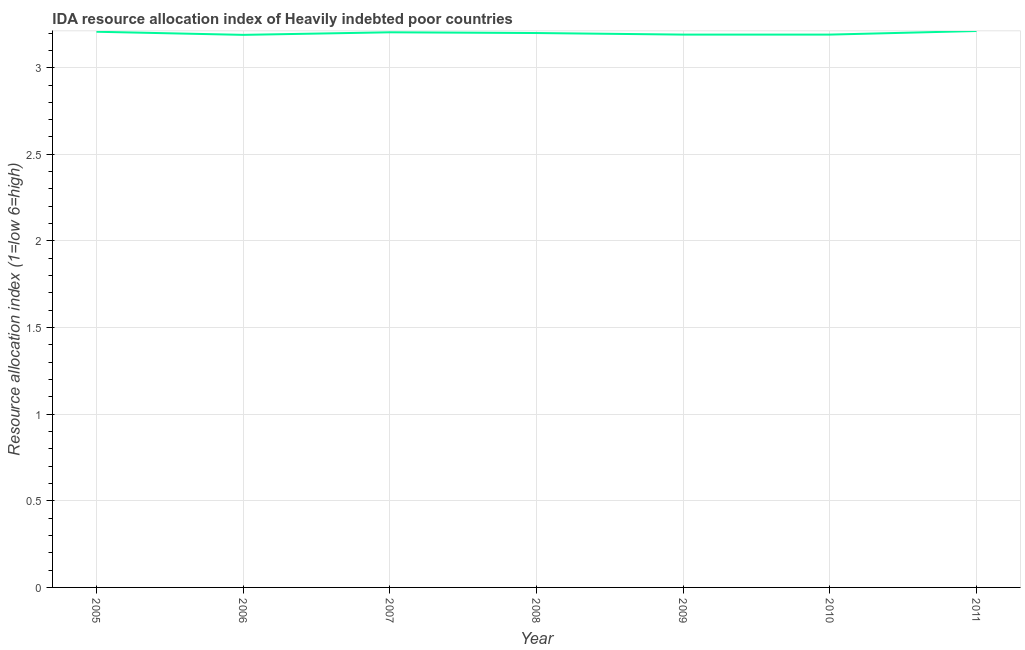What is the ida resource allocation index in 2011?
Offer a terse response. 3.21. Across all years, what is the maximum ida resource allocation index?
Offer a terse response. 3.21. Across all years, what is the minimum ida resource allocation index?
Provide a succinct answer. 3.19. In which year was the ida resource allocation index maximum?
Your answer should be very brief. 2011. What is the sum of the ida resource allocation index?
Provide a short and direct response. 22.39. What is the difference between the ida resource allocation index in 2006 and 2007?
Your response must be concise. -0.01. What is the average ida resource allocation index per year?
Make the answer very short. 3.2. Do a majority of the years between 2009 and 2011 (inclusive) have ida resource allocation index greater than 1.5 ?
Your answer should be very brief. Yes. Is the ida resource allocation index in 2009 less than that in 2010?
Offer a terse response. No. Is the difference between the ida resource allocation index in 2010 and 2011 greater than the difference between any two years?
Keep it short and to the point. No. What is the difference between the highest and the second highest ida resource allocation index?
Your answer should be very brief. 0. What is the difference between the highest and the lowest ida resource allocation index?
Provide a short and direct response. 0.02. What is the difference between two consecutive major ticks on the Y-axis?
Provide a succinct answer. 0.5. Are the values on the major ticks of Y-axis written in scientific E-notation?
Give a very brief answer. No. Does the graph contain any zero values?
Offer a very short reply. No. Does the graph contain grids?
Offer a terse response. Yes. What is the title of the graph?
Give a very brief answer. IDA resource allocation index of Heavily indebted poor countries. What is the label or title of the Y-axis?
Provide a succinct answer. Resource allocation index (1=low 6=high). What is the Resource allocation index (1=low 6=high) of 2005?
Your response must be concise. 3.21. What is the Resource allocation index (1=low 6=high) in 2006?
Your answer should be compact. 3.19. What is the Resource allocation index (1=low 6=high) of 2007?
Make the answer very short. 3.2. What is the Resource allocation index (1=low 6=high) in 2008?
Make the answer very short. 3.2. What is the Resource allocation index (1=low 6=high) of 2009?
Offer a very short reply. 3.19. What is the Resource allocation index (1=low 6=high) in 2010?
Your response must be concise. 3.19. What is the Resource allocation index (1=low 6=high) in 2011?
Ensure brevity in your answer.  3.21. What is the difference between the Resource allocation index (1=low 6=high) in 2005 and 2006?
Offer a terse response. 0.02. What is the difference between the Resource allocation index (1=low 6=high) in 2005 and 2007?
Ensure brevity in your answer.  0. What is the difference between the Resource allocation index (1=low 6=high) in 2005 and 2008?
Give a very brief answer. 0.01. What is the difference between the Resource allocation index (1=low 6=high) in 2005 and 2009?
Keep it short and to the point. 0.02. What is the difference between the Resource allocation index (1=low 6=high) in 2005 and 2010?
Your answer should be very brief. 0.02. What is the difference between the Resource allocation index (1=low 6=high) in 2005 and 2011?
Provide a short and direct response. -0. What is the difference between the Resource allocation index (1=low 6=high) in 2006 and 2007?
Provide a succinct answer. -0.01. What is the difference between the Resource allocation index (1=low 6=high) in 2006 and 2008?
Provide a succinct answer. -0.01. What is the difference between the Resource allocation index (1=low 6=high) in 2006 and 2009?
Your response must be concise. -0. What is the difference between the Resource allocation index (1=low 6=high) in 2006 and 2010?
Your response must be concise. -0. What is the difference between the Resource allocation index (1=low 6=high) in 2006 and 2011?
Give a very brief answer. -0.02. What is the difference between the Resource allocation index (1=low 6=high) in 2007 and 2008?
Provide a succinct answer. 0. What is the difference between the Resource allocation index (1=low 6=high) in 2007 and 2009?
Your response must be concise. 0.01. What is the difference between the Resource allocation index (1=low 6=high) in 2007 and 2010?
Provide a succinct answer. 0.01. What is the difference between the Resource allocation index (1=low 6=high) in 2007 and 2011?
Make the answer very short. -0.01. What is the difference between the Resource allocation index (1=low 6=high) in 2008 and 2009?
Keep it short and to the point. 0.01. What is the difference between the Resource allocation index (1=low 6=high) in 2008 and 2010?
Ensure brevity in your answer.  0.01. What is the difference between the Resource allocation index (1=low 6=high) in 2008 and 2011?
Give a very brief answer. -0.01. What is the difference between the Resource allocation index (1=low 6=high) in 2009 and 2010?
Your answer should be very brief. 0. What is the difference between the Resource allocation index (1=low 6=high) in 2009 and 2011?
Provide a succinct answer. -0.02. What is the difference between the Resource allocation index (1=low 6=high) in 2010 and 2011?
Provide a succinct answer. -0.02. What is the ratio of the Resource allocation index (1=low 6=high) in 2005 to that in 2008?
Offer a terse response. 1. What is the ratio of the Resource allocation index (1=low 6=high) in 2005 to that in 2011?
Ensure brevity in your answer.  1. What is the ratio of the Resource allocation index (1=low 6=high) in 2006 to that in 2011?
Make the answer very short. 0.99. What is the ratio of the Resource allocation index (1=low 6=high) in 2007 to that in 2010?
Give a very brief answer. 1. What is the ratio of the Resource allocation index (1=low 6=high) in 2007 to that in 2011?
Give a very brief answer. 1. What is the ratio of the Resource allocation index (1=low 6=high) in 2008 to that in 2011?
Your response must be concise. 1. What is the ratio of the Resource allocation index (1=low 6=high) in 2009 to that in 2010?
Provide a short and direct response. 1. What is the ratio of the Resource allocation index (1=low 6=high) in 2009 to that in 2011?
Make the answer very short. 0.99. 